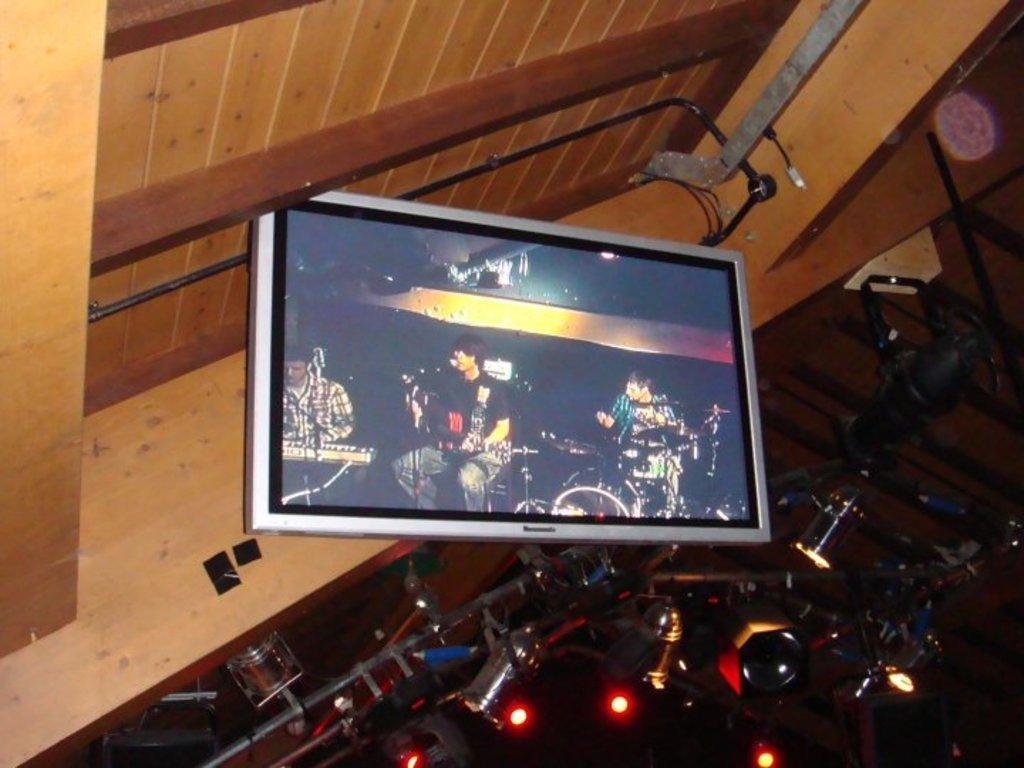Please provide a concise description of this image. In this image there are lights, rods, screen, roof and objects. On the screen I can see people playing musical instruments in-front of the mics.   